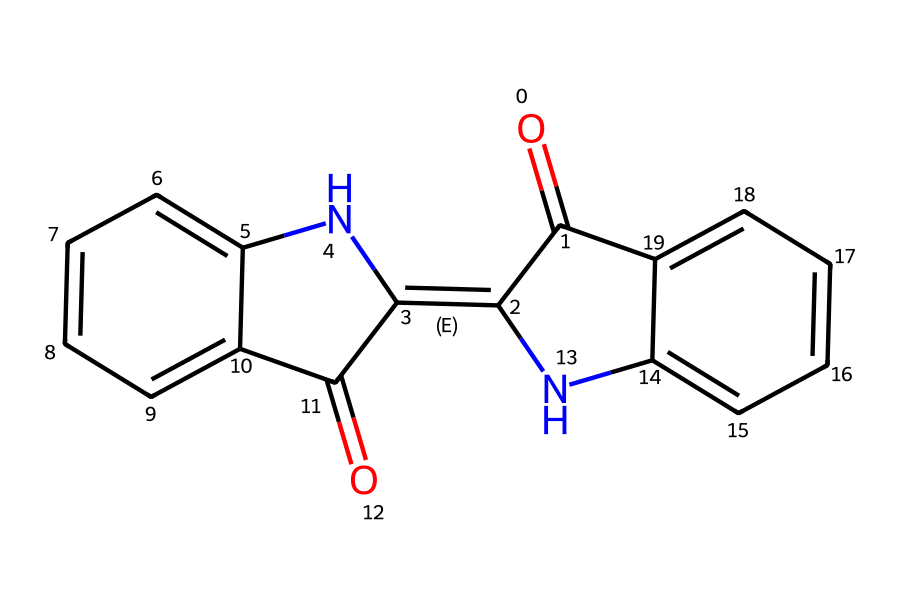What is the molecular formula of the coordination compound in the pigment? By analyzing the structure and counting the elements present, the molecular formula is determined to be C15H10N2O2. The chemical contains 15 carbon (C) atoms, 10 hydrogen (H) atoms, 2 nitrogen (N) atoms, and 2 oxygen (O) atoms.
Answer: C15H10N2O2 How many rings are present in the structure? The structure exhibits three distinct rings, as can be identified by the cyclic arrangements formed by the connected carbon atoms. Each ring contributes to the compound's overall stability and properties.
Answer: 3 What functional groups are present in the molecule? The structure reveals two functional groups: the carbonyl group (C=O) located at the beginning, and the imine (N=C) functional group that forms part of the ring structures. These groups significantly influence the chemical's color and reactivity.
Answer: carbonyl and imine Does the compound have any nitrogen atoms in its structure? By examining the structure, we can observe that there are indeed two nitrogen atoms present, contributing to the molecule's potential coordination and bonding characteristics. This is relevant in determining the pigment's interaction with metallic ions.
Answer: Yes What type of coordination compound is this pigment classified as? This pigment is classified as a metal complex, specifically a coordination compound because of its ability to coordinate with metal ions, which enhances the pigment's properties and stability, particularly relevant in pigments.
Answer: metal complex What is the color typically associated with the pigment derived from this structure? The compound structure, featuring conjugated double bonds and certain functional groups, is commonly associated with a blue or blue-green color, often used in various pigments, including those seen in Real Madrid jerseys.
Answer: blue 